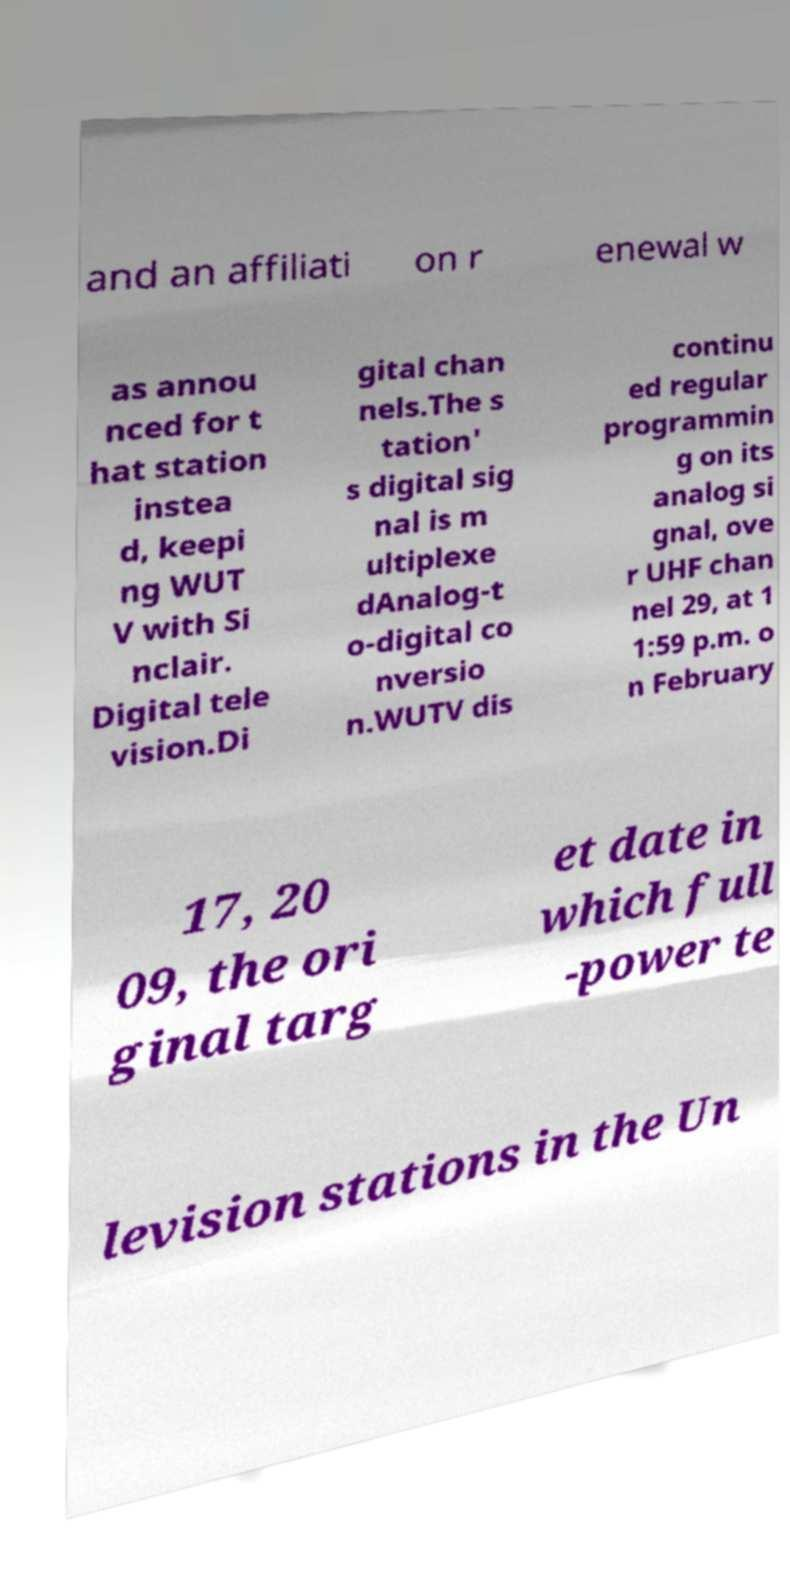There's text embedded in this image that I need extracted. Can you transcribe it verbatim? and an affiliati on r enewal w as annou nced for t hat station instea d, keepi ng WUT V with Si nclair. Digital tele vision.Di gital chan nels.The s tation' s digital sig nal is m ultiplexe dAnalog-t o-digital co nversio n.WUTV dis continu ed regular programmin g on its analog si gnal, ove r UHF chan nel 29, at 1 1:59 p.m. o n February 17, 20 09, the ori ginal targ et date in which full -power te levision stations in the Un 